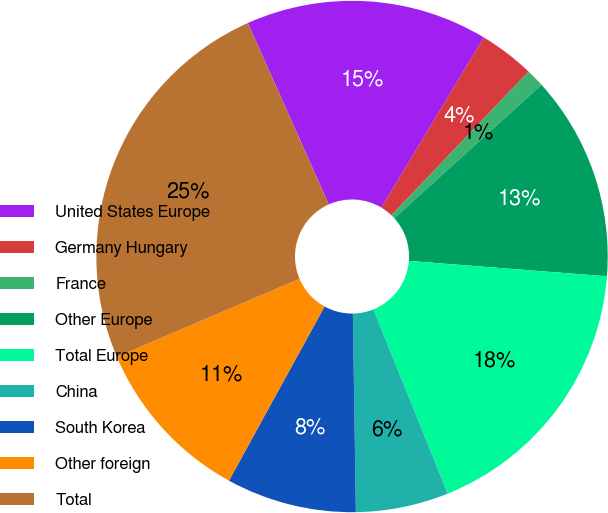<chart> <loc_0><loc_0><loc_500><loc_500><pie_chart><fcel>United States Europe<fcel>Germany Hungary<fcel>France<fcel>Other Europe<fcel>Total Europe<fcel>China<fcel>South Korea<fcel>Other foreign<fcel>Total<nl><fcel>15.3%<fcel>3.51%<fcel>1.15%<fcel>12.95%<fcel>17.66%<fcel>5.87%<fcel>8.23%<fcel>10.59%<fcel>24.74%<nl></chart> 